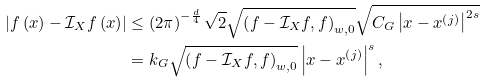Convert formula to latex. <formula><loc_0><loc_0><loc_500><loc_500>\left | f \left ( x \right ) - \mathcal { I } _ { X } f \left ( x \right ) \right | & \leq \left ( 2 \pi \right ) ^ { - \frac { d } { 4 } } \sqrt { 2 } \sqrt { \left ( f - \mathcal { I } _ { X } f , f \right ) _ { w , 0 } } \sqrt { C _ { G } \left | x - x ^ { \left ( j \right ) } \right | ^ { 2 s } } \\ & = k _ { G } \sqrt { \left ( f - \mathcal { I } _ { X } f , f \right ) _ { w , 0 } } \left | x - x ^ { \left ( j \right ) } \right | ^ { s } ,</formula> 